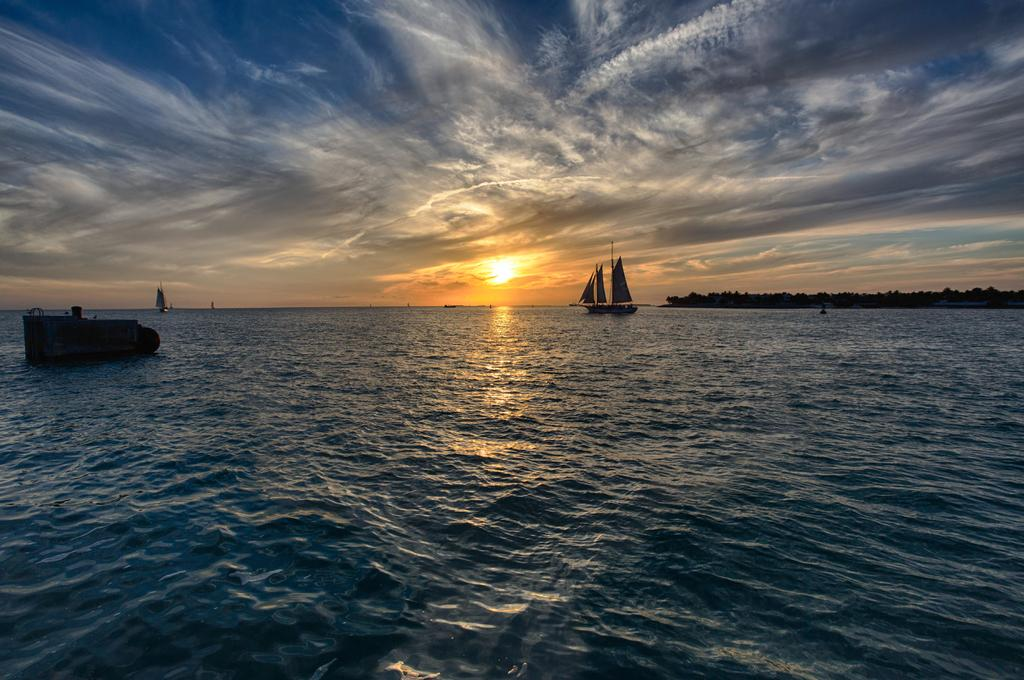What type of vehicles are in the water in the image? There are boats in the water in the image. What type of vegetation can be seen in the image? There are trees visible in the image. What is visible in the background of the image? The sky is visible in the background of the image. What can be observed in the sky? Clouds are present in the sky. What type of acoustics can be heard from the boats in the image? There is no information about the acoustics of the boats in the image, as it only provides visual information. 